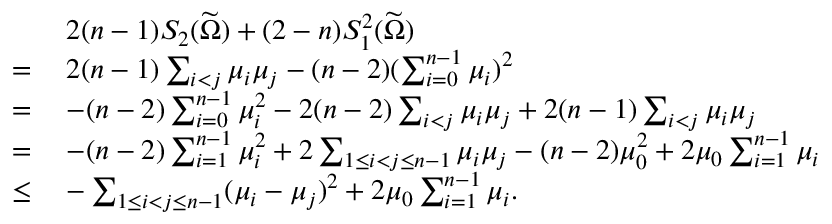<formula> <loc_0><loc_0><loc_500><loc_500>\begin{array} { r l } & { \, 2 ( n - 1 ) S _ { 2 } ( \widetilde { \Omega } ) + ( 2 - n ) S _ { 1 } ^ { 2 } ( \widetilde { \Omega } ) } \\ { = } & { \, 2 ( n - 1 ) \sum _ { i < j } \mu _ { i } \mu _ { j } - ( n - 2 ) ( \sum _ { i = 0 } ^ { n - 1 } \mu _ { i } ) ^ { 2 } } \\ { = } & { \, - ( n - 2 ) \sum _ { i = 0 } ^ { n - 1 } \mu _ { i } ^ { 2 } - 2 ( n - 2 ) \sum _ { i < j } \mu _ { i } \mu _ { j } + 2 ( n - 1 ) \sum _ { i < j } \mu _ { i } \mu _ { j } } \\ { = } & { \, - ( n - 2 ) \sum _ { i = 1 } ^ { n - 1 } \mu _ { i } ^ { 2 } + 2 \sum _ { 1 \leq i < j \leq n - 1 } \mu _ { i } \mu _ { j } - ( n - 2 ) \mu _ { 0 } ^ { 2 } + 2 \mu _ { 0 } \sum _ { i = 1 } ^ { n - 1 } \mu _ { i } } \\ { \leq } & { \, - \sum _ { 1 \leq i < j \leq n - 1 } ( \mu _ { i } - \mu _ { j } ) ^ { 2 } + 2 \mu _ { 0 } \sum _ { i = 1 } ^ { n - 1 } \mu _ { i } . } \end{array}</formula> 